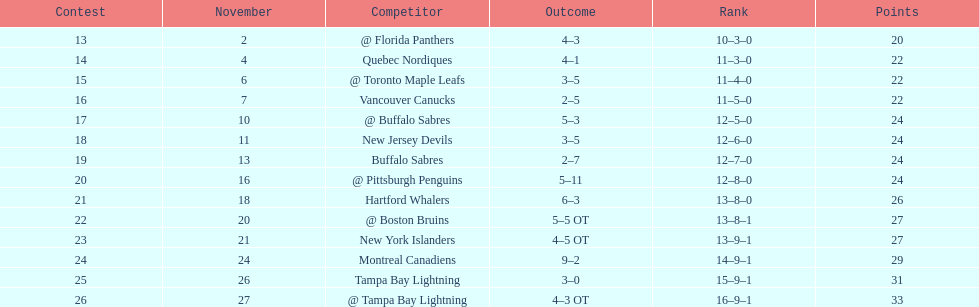Which was the only team in the atlantic division in the 1993-1994 season to acquire less points than the philadelphia flyers? Tampa Bay Lightning. 